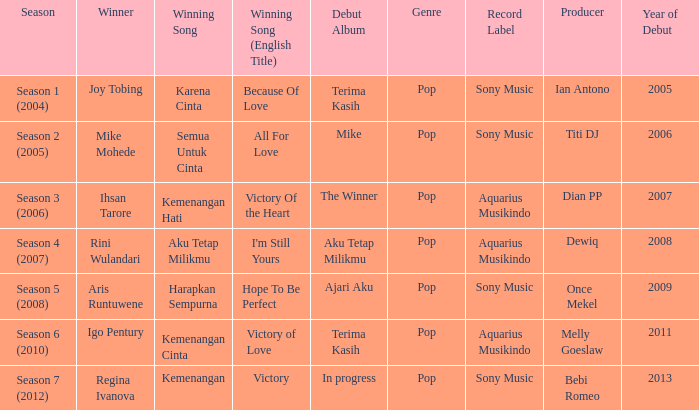Which winning song was sung by aku tetap milikmu? I'm Still Yours. 